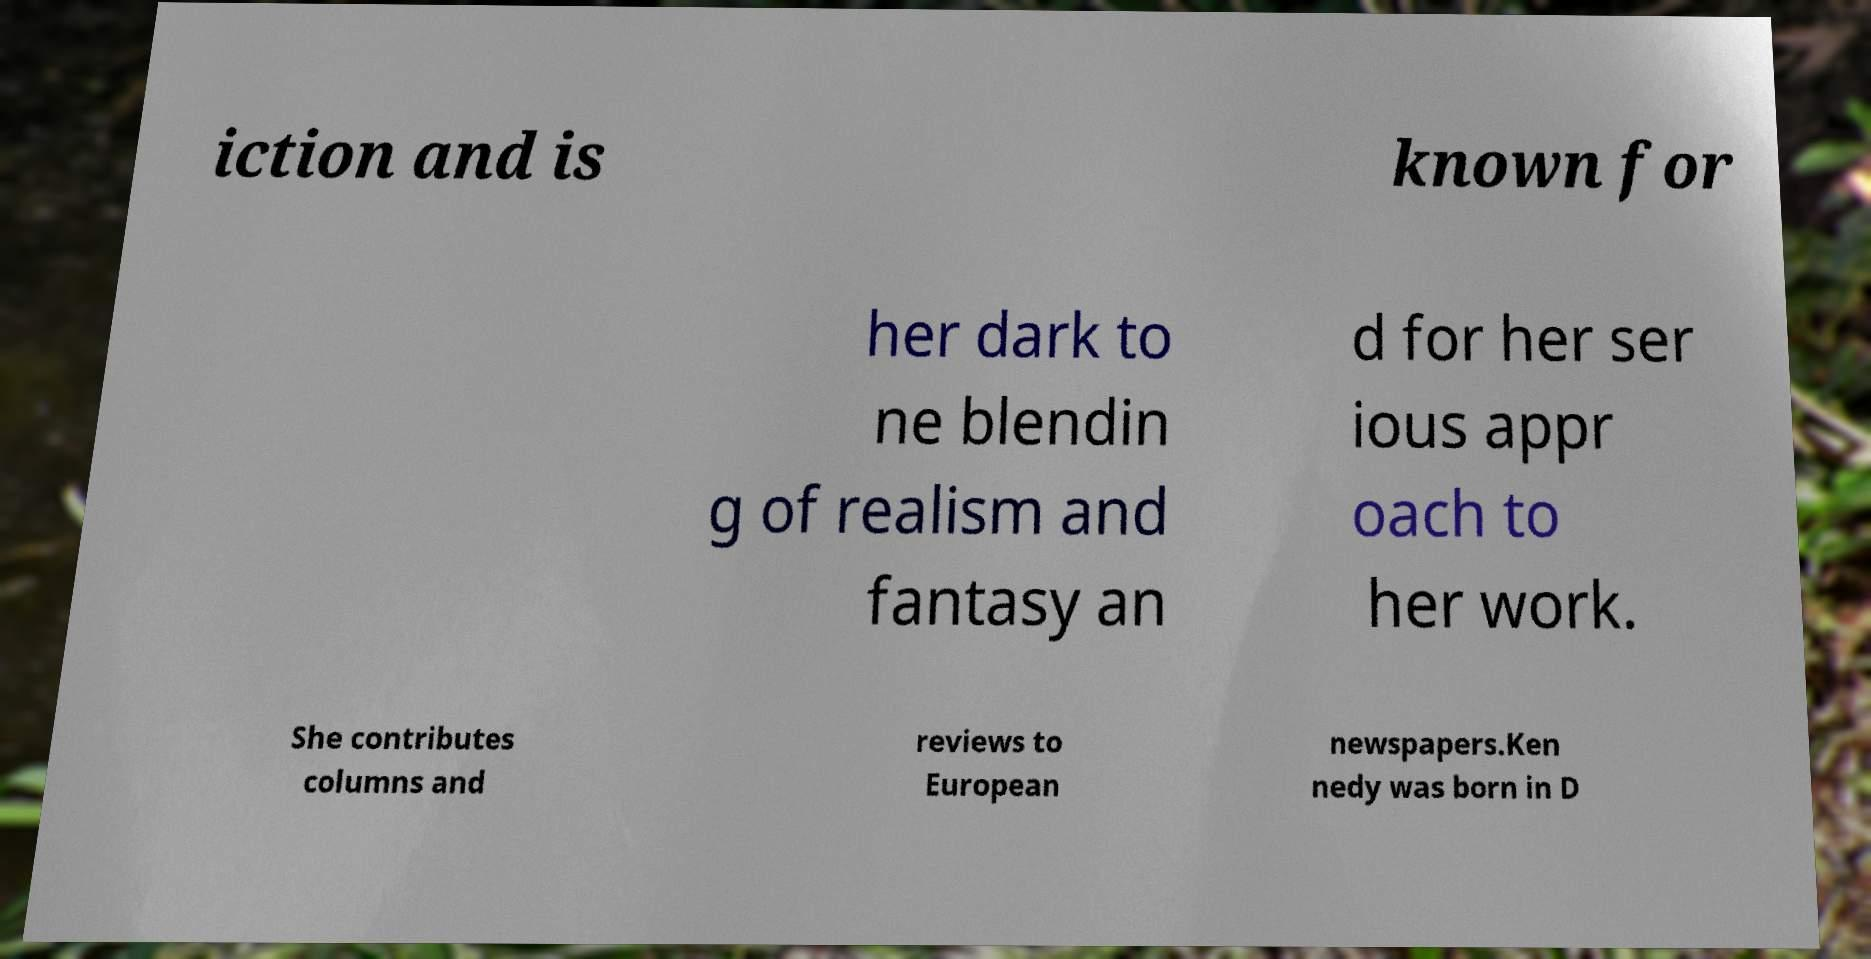Please read and relay the text visible in this image. What does it say? iction and is known for her dark to ne blendin g of realism and fantasy an d for her ser ious appr oach to her work. She contributes columns and reviews to European newspapers.Ken nedy was born in D 